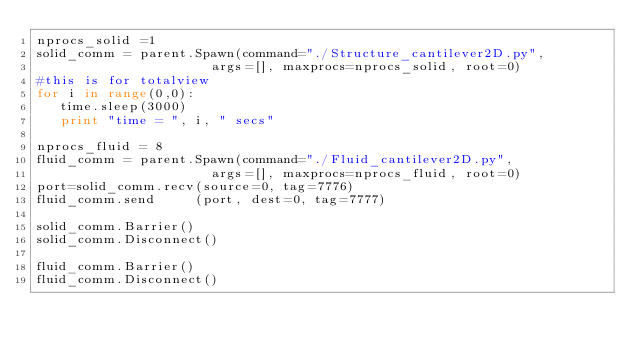Convert code to text. <code><loc_0><loc_0><loc_500><loc_500><_Python_>nprocs_solid =1  
solid_comm = parent.Spawn(command="./Structure_cantilever2D.py",   
                      args=[], maxprocs=nprocs_solid, root=0)
#this is for totalview
for i in range(0,0):
   time.sleep(3000)		    
   print "time = ", i, " secs"

nprocs_fluid = 8 
fluid_comm = parent.Spawn(command="./Fluid_cantilever2D.py", 
                      args=[], maxprocs=nprocs_fluid, root=0)
port=solid_comm.recv(source=0, tag=7776)
fluid_comm.send     (port, dest=0, tag=7777)

solid_comm.Barrier()
solid_comm.Disconnect()

fluid_comm.Barrier()
fluid_comm.Disconnect()


</code> 